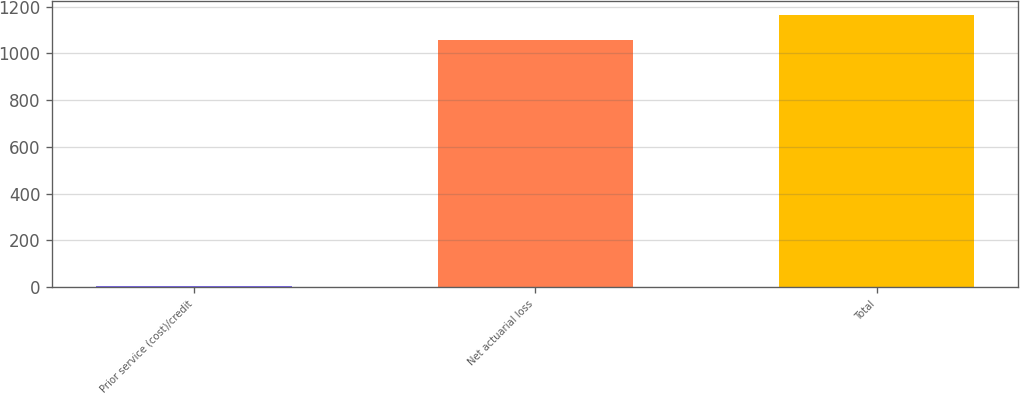<chart> <loc_0><loc_0><loc_500><loc_500><bar_chart><fcel>Prior service (cost)/credit<fcel>Net actuarial loss<fcel>Total<nl><fcel>3<fcel>1059<fcel>1164.9<nl></chart> 